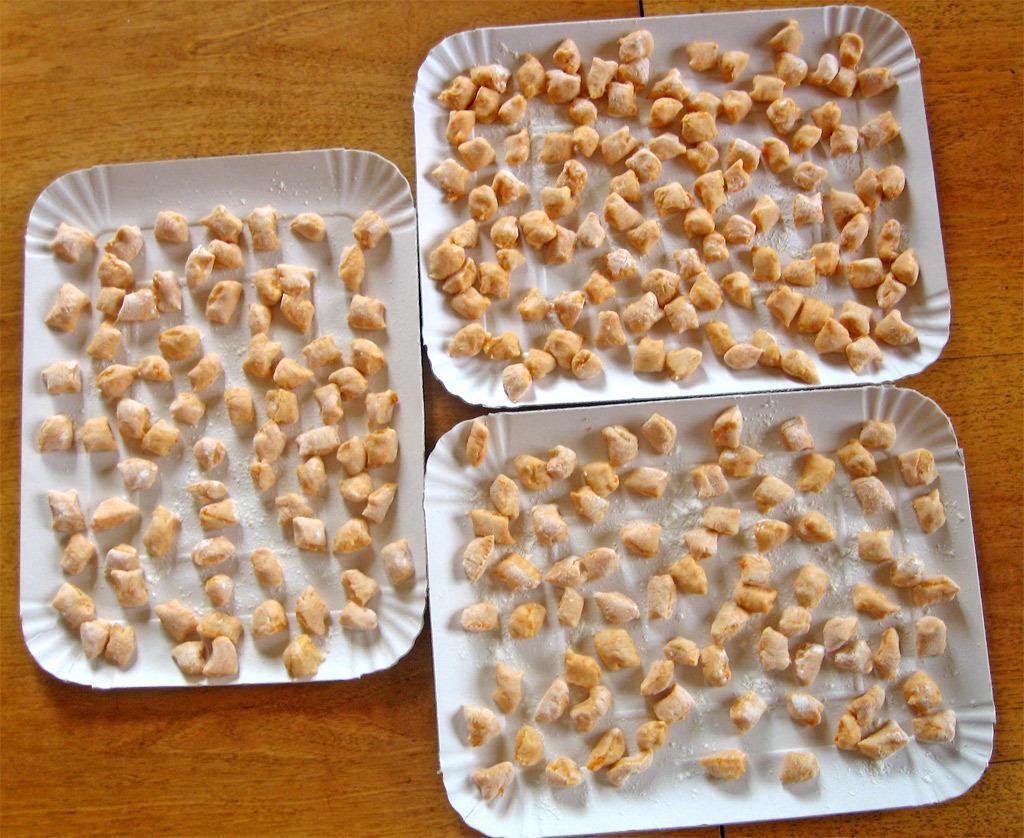Describe this image in one or two sentences. In this image there is a table with three trays of sweets on it. 